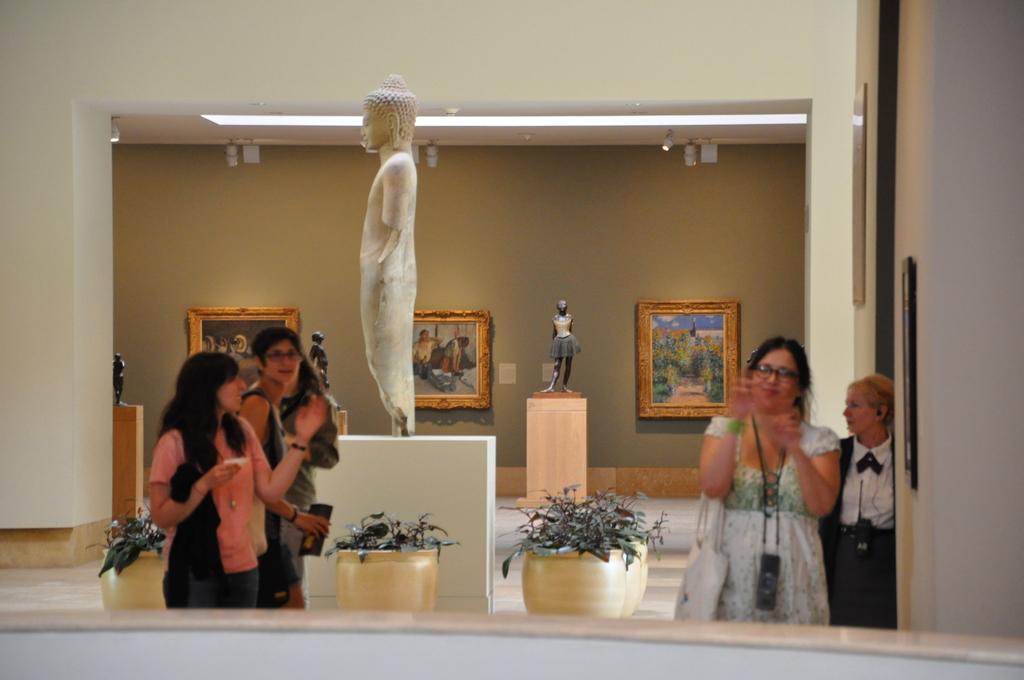In one or two sentences, can you explain what this image depicts? In this image we can see a few people standing, among them some people are holding the objects, there are some statues, flowers pots and lights, also we can see some photo frames on the wall. 